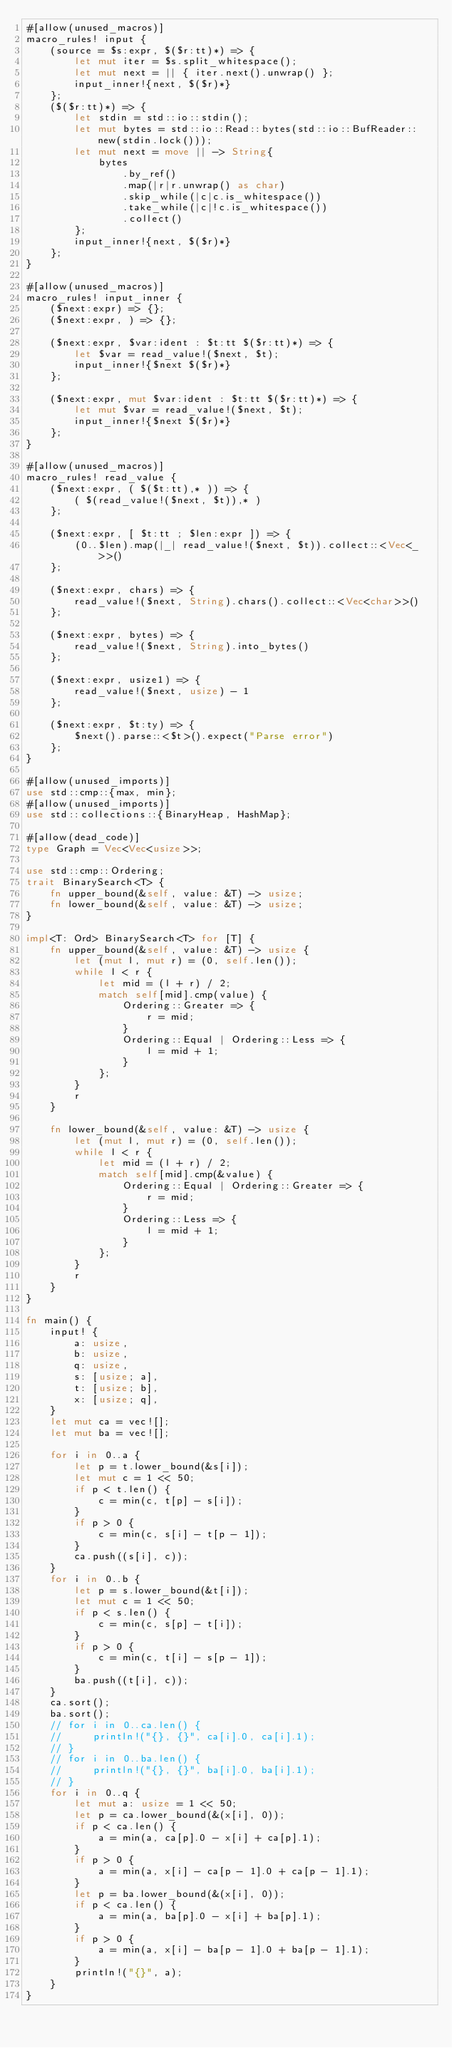<code> <loc_0><loc_0><loc_500><loc_500><_Rust_>#[allow(unused_macros)]
macro_rules! input {
    (source = $s:expr, $($r:tt)*) => {
        let mut iter = $s.split_whitespace();
        let mut next = || { iter.next().unwrap() };
        input_inner!{next, $($r)*}
    };
    ($($r:tt)*) => {
        let stdin = std::io::stdin();
        let mut bytes = std::io::Read::bytes(std::io::BufReader::new(stdin.lock()));
        let mut next = move || -> String{
            bytes
                .by_ref()
                .map(|r|r.unwrap() as char)
                .skip_while(|c|c.is_whitespace())
                .take_while(|c|!c.is_whitespace())
                .collect()
        };
        input_inner!{next, $($r)*}
    };
}

#[allow(unused_macros)]
macro_rules! input_inner {
    ($next:expr) => {};
    ($next:expr, ) => {};

    ($next:expr, $var:ident : $t:tt $($r:tt)*) => {
        let $var = read_value!($next, $t);
        input_inner!{$next $($r)*}
    };

    ($next:expr, mut $var:ident : $t:tt $($r:tt)*) => {
        let mut $var = read_value!($next, $t);
        input_inner!{$next $($r)*}
    };
}

#[allow(unused_macros)]
macro_rules! read_value {
    ($next:expr, ( $($t:tt),* )) => {
        ( $(read_value!($next, $t)),* )
    };

    ($next:expr, [ $t:tt ; $len:expr ]) => {
        (0..$len).map(|_| read_value!($next, $t)).collect::<Vec<_>>()
    };

    ($next:expr, chars) => {
        read_value!($next, String).chars().collect::<Vec<char>>()
    };

    ($next:expr, bytes) => {
        read_value!($next, String).into_bytes()
    };

    ($next:expr, usize1) => {
        read_value!($next, usize) - 1
    };

    ($next:expr, $t:ty) => {
        $next().parse::<$t>().expect("Parse error")
    };
}

#[allow(unused_imports)]
use std::cmp::{max, min};
#[allow(unused_imports)]
use std::collections::{BinaryHeap, HashMap};

#[allow(dead_code)]
type Graph = Vec<Vec<usize>>;

use std::cmp::Ordering;
trait BinarySearch<T> {
    fn upper_bound(&self, value: &T) -> usize;
    fn lower_bound(&self, value: &T) -> usize;
}

impl<T: Ord> BinarySearch<T> for [T] {
    fn upper_bound(&self, value: &T) -> usize {
        let (mut l, mut r) = (0, self.len());
        while l < r {
            let mid = (l + r) / 2;
            match self[mid].cmp(value) {
                Ordering::Greater => {
                    r = mid;
                }
                Ordering::Equal | Ordering::Less => {
                    l = mid + 1;
                }
            };
        }
        r
    }

    fn lower_bound(&self, value: &T) -> usize {
        let (mut l, mut r) = (0, self.len());
        while l < r {
            let mid = (l + r) / 2;
            match self[mid].cmp(&value) {
                Ordering::Equal | Ordering::Greater => {
                    r = mid;
                }
                Ordering::Less => {
                    l = mid + 1;
                }
            };
        }
        r
    }
}

fn main() {
    input! {
        a: usize,
        b: usize,
        q: usize,
        s: [usize; a],
        t: [usize; b],
        x: [usize; q],
    }
    let mut ca = vec![];
    let mut ba = vec![];

    for i in 0..a {
        let p = t.lower_bound(&s[i]);
        let mut c = 1 << 50;
        if p < t.len() {
            c = min(c, t[p] - s[i]);
        }
        if p > 0 {
            c = min(c, s[i] - t[p - 1]);
        }
        ca.push((s[i], c));
    }
    for i in 0..b {
        let p = s.lower_bound(&t[i]);
        let mut c = 1 << 50;
        if p < s.len() {
            c = min(c, s[p] - t[i]);
        }
        if p > 0 {
            c = min(c, t[i] - s[p - 1]);
        }
        ba.push((t[i], c));
    }
    ca.sort();
    ba.sort();
    // for i in 0..ca.len() {
    //     println!("{}, {}", ca[i].0, ca[i].1);
    // }
    // for i in 0..ba.len() {
    //     println!("{}, {}", ba[i].0, ba[i].1);
    // }
    for i in 0..q {
        let mut a: usize = 1 << 50;
        let p = ca.lower_bound(&(x[i], 0));
        if p < ca.len() {
            a = min(a, ca[p].0 - x[i] + ca[p].1);
        }
        if p > 0 {
            a = min(a, x[i] - ca[p - 1].0 + ca[p - 1].1);
        }
        let p = ba.lower_bound(&(x[i], 0));
        if p < ca.len() {
            a = min(a, ba[p].0 - x[i] + ba[p].1);
        }
        if p > 0 {
            a = min(a, x[i] - ba[p - 1].0 + ba[p - 1].1);
        }
        println!("{}", a);
    }
}
</code> 